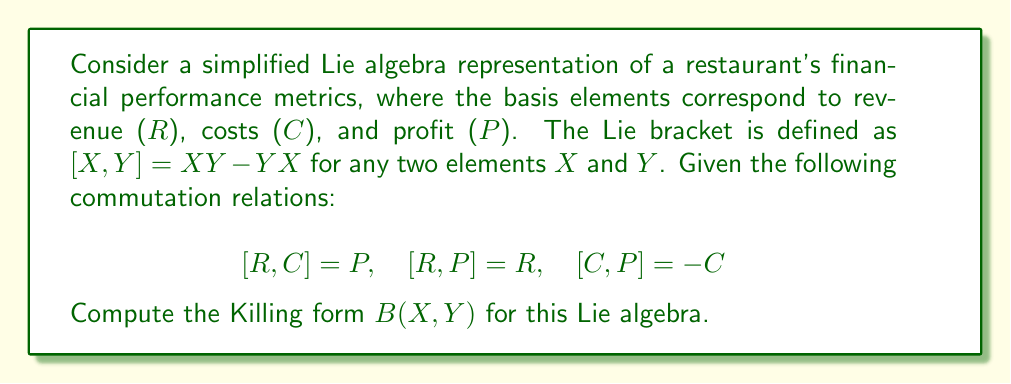Can you solve this math problem? To compute the Killing form for this Lie algebra, we follow these steps:

1) The Killing form is defined as $B(X, Y) = \text{tr}(\text{ad}_X \circ \text{ad}_Y)$, where $\text{ad}_X$ is the adjoint representation of $X$.

2) We need to calculate the adjoint representations for each basis element:

   For $R$: $\text{ad}_R(C) = [R, C] = P$, $\text{ad}_R(P) = [R, P] = R$, $\text{ad}_R(R) = 0$
   For $C$: $\text{ad}_C(R) = [C, R] = -P$, $\text{ad}_C(P) = [C, P] = -C$, $\text{ad}_C(C) = 0$
   For $P$: $\text{ad}_P(R) = [P, R] = -R$, $\text{ad}_P(C) = [P, C] = C$, $\text{ad}_P(P) = 0$

3) We can represent these adjoint operators as matrices:

   $$\text{ad}_R = \begin{pmatrix} 0 & 0 & 1 \\ 0 & 0 & 0 \\ 0 & 1 & 0 \end{pmatrix}$$
   $$\text{ad}_C = \begin{pmatrix} 0 & 0 & 0 \\ 0 & 0 & -1 \\ -1 & 0 & 0 \end{pmatrix}$$
   $$\text{ad}_P = \begin{pmatrix} -1 & 0 & 0 \\ 0 & 1 & 0 \\ 0 & 0 & 0 \end{pmatrix}$$

4) Now, we compute $B(X, Y)$ for all pairs of basis elements:

   $B(R, R) = \text{tr}(\text{ad}_R \circ \text{ad}_R) = 0$
   $B(R, C) = \text{tr}(\text{ad}_R \circ \text{ad}_C) = -1$
   $B(R, P) = \text{tr}(\text{ad}_R \circ \text{ad}_P) = -1$
   $B(C, R) = \text{tr}(\text{ad}_C \circ \text{ad}_R) = -1$
   $B(C, C) = \text{tr}(\text{ad}_C \circ \text{ad}_C) = 0$
   $B(C, P) = \text{tr}(\text{ad}_C \circ \text{ad}_P) = 1$
   $B(P, R) = \text{tr}(\text{ad}_P \circ \text{ad}_R) = -1$
   $B(P, C) = \text{tr}(\text{ad}_P \circ \text{ad}_C) = 1$
   $B(P, P) = \text{tr}(\text{ad}_P \circ \text{ad}_P) = 2$

5) The Killing form can be represented as a matrix:

   $$B = \begin{pmatrix} 0 & -1 & -1 \\ -1 & 0 & 1 \\ -1 & 1 & 2 \end{pmatrix}$$

This matrix represents the Killing form for the given Lie algebra of restaurant financial performance metrics.
Answer: The Killing form for the given Lie algebra is:

$$B = \begin{pmatrix} 0 & -1 & -1 \\ -1 & 0 & 1 \\ -1 & 1 & 2 \end{pmatrix}$$ 